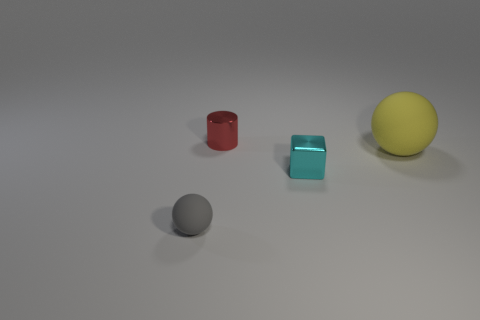Add 3 yellow matte objects. How many objects exist? 7 Subtract 1 yellow spheres. How many objects are left? 3 Subtract all cylinders. How many objects are left? 3 Subtract all small cyan rubber objects. Subtract all big objects. How many objects are left? 3 Add 2 small cyan shiny things. How many small cyan shiny things are left? 3 Add 1 rubber cylinders. How many rubber cylinders exist? 1 